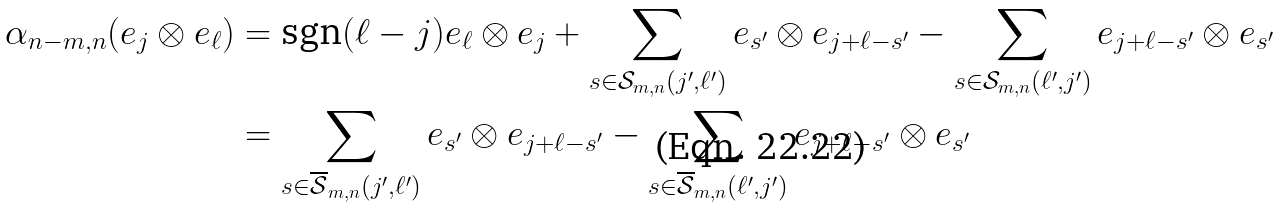<formula> <loc_0><loc_0><loc_500><loc_500>\alpha _ { n - m , n } ( e _ { j } \otimes e _ { \ell } ) & = \text {sgn} ( \ell - j ) e _ { \ell } \otimes e _ { j } + \sum _ { s \in { \mathcal { S } } _ { m , n } ( j ^ { \prime } , \ell ^ { \prime } ) } e _ { s ^ { \prime } } \otimes e _ { j + \ell - s ^ { \prime } } - \sum _ { s \in { \mathcal { S } } _ { m , n } ( \ell ^ { \prime } , j ^ { \prime } ) } e _ { j + \ell - s ^ { \prime } } \otimes e _ { s ^ { \prime } } \\ & = \sum _ { s \in \overline { \mathcal { S } } _ { m , n } ( j ^ { \prime } , \ell ^ { \prime } ) } e _ { s ^ { \prime } } \otimes e _ { j + \ell - s ^ { \prime } } - \sum _ { s \in \overline { \mathcal { S } } _ { m , n } ( \ell ^ { \prime } , j ^ { \prime } ) } e _ { j + \ell - s ^ { \prime } } \otimes e _ { s ^ { \prime } }</formula> 